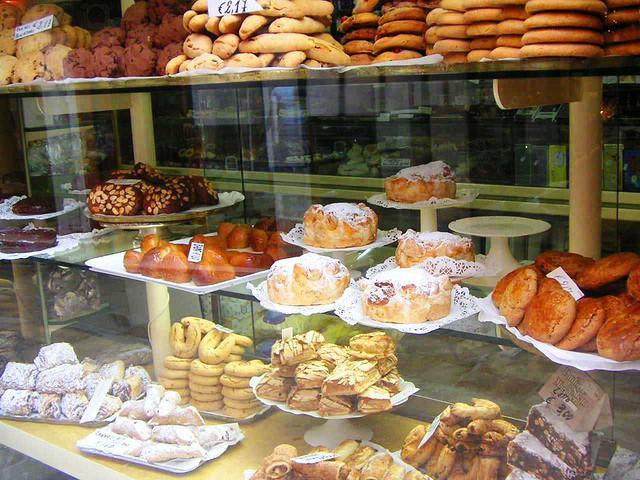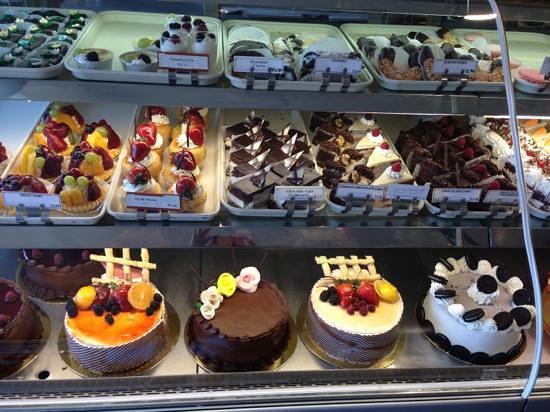The first image is the image on the left, the second image is the image on the right. For the images shown, is this caption "At least one person is in one image behind a filled bakery display case with three or more shelves and a glass front" true? Answer yes or no. No. 